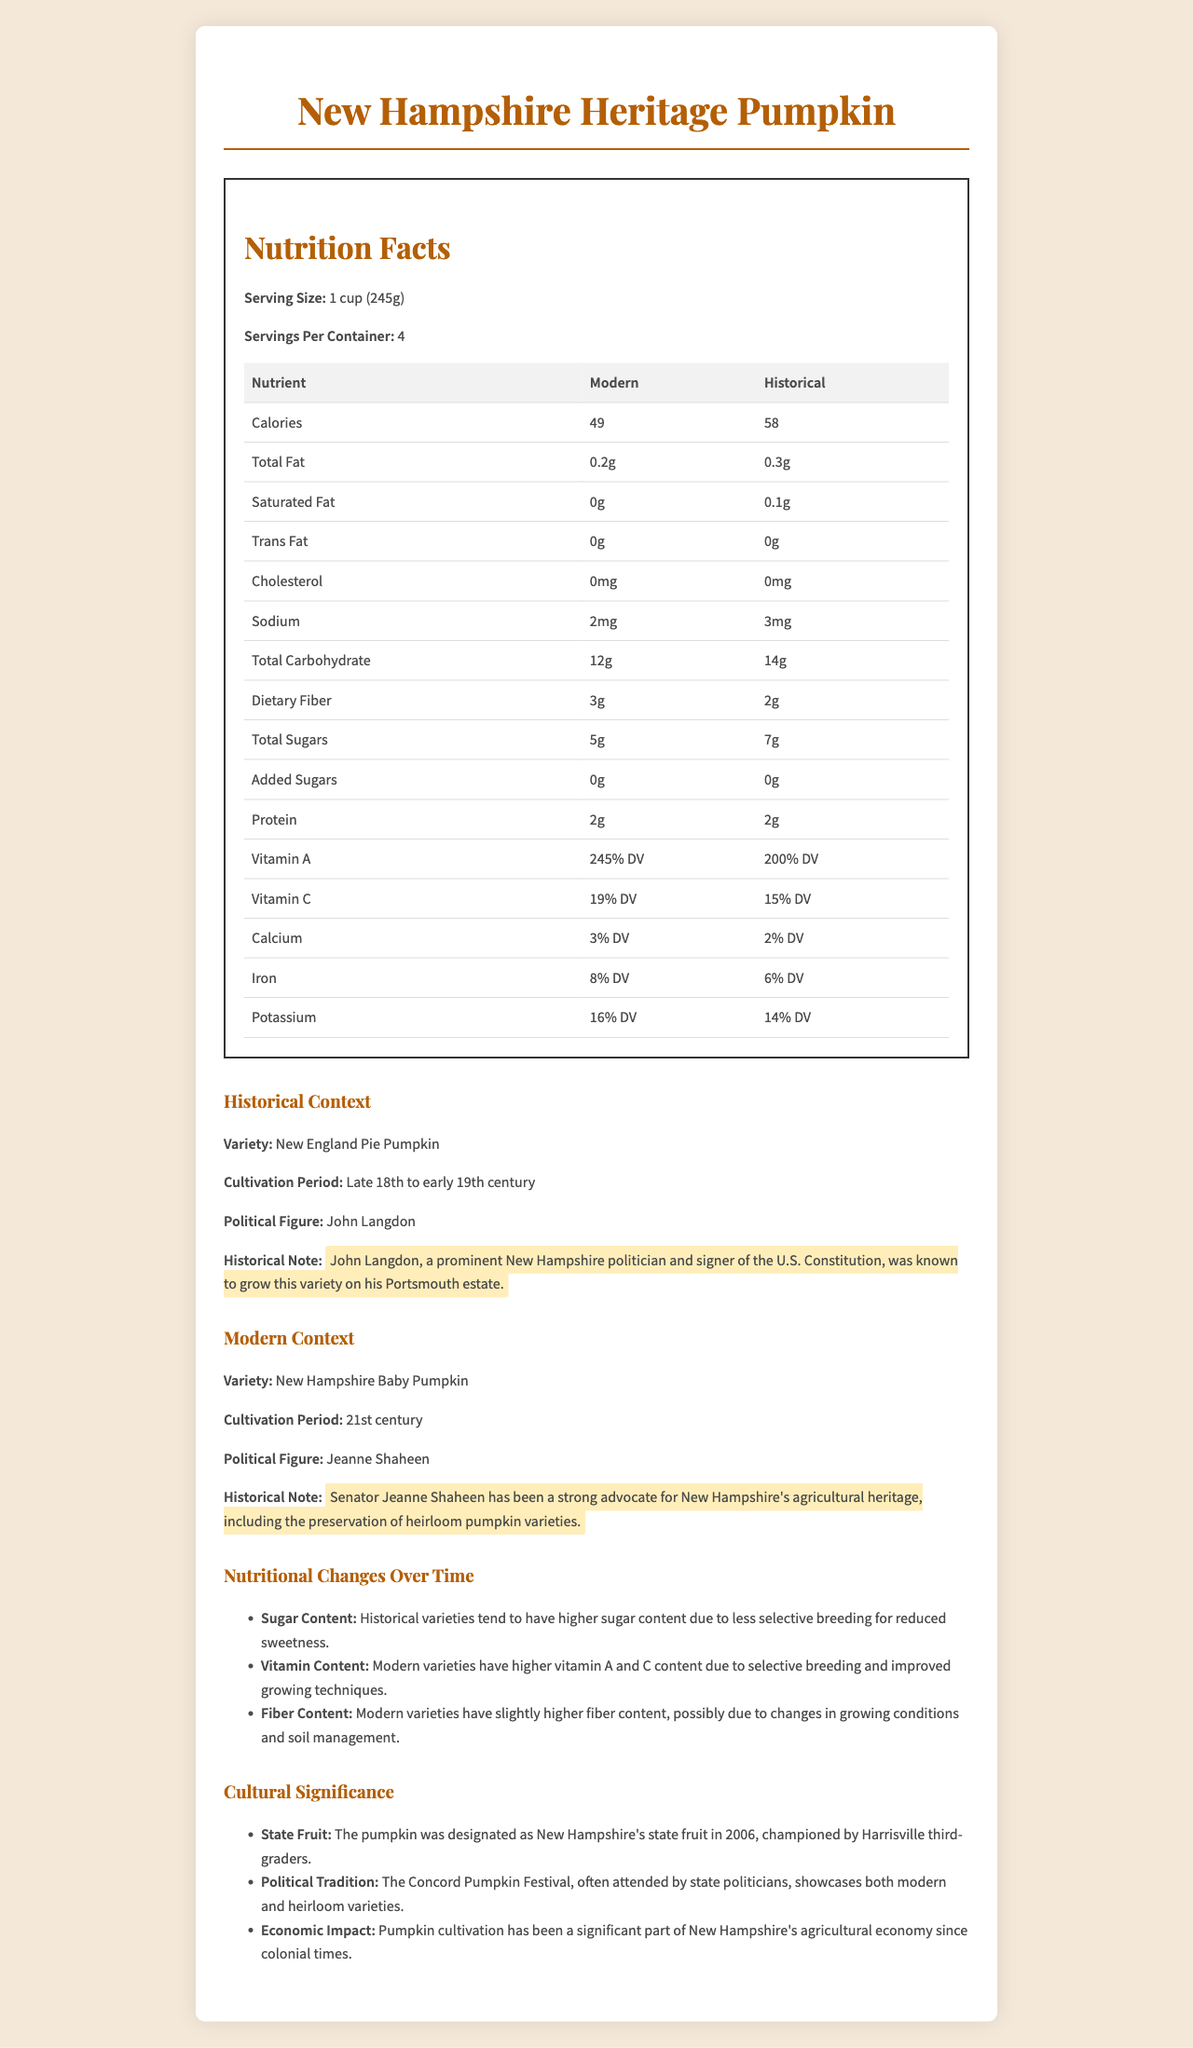what is the serving size for the New Hampshire Heritage Pumpkin? The serving size is explicitly mentioned under the Nutrition Facts section in the document.
Answer: 1 cup (245g) how many servings are there per container? The document clearly states that there are 4 servings per container.
Answer: 4 what period was the New England Pie Pumpkin cultivated? This information is given in the Historical Context section.
Answer: Late 18th to early 19th century who is the modern political figure associated with the New Hampshire Baby Pumpkin? This information is provided in the Modern Context section.
Answer: Jeanne Shaheen how does the fiber content of modern pumpkin compare to historical pumpkin? The modern variety has 3g of dietary fiber, while the historical variety has 2g.
Answer: Modern pumpkin has 1g more fiber than historical pumpkin how much vitamin A does the modern version of the pumpkin provide? A. 200% DV B. 245% DV C. 100% DV The modern version contains 245% DV of vitamin A as specified in the document.
Answer: B which variety has higher total sugars? I. Modern II. Historical The historical variety has 7g of total sugars while the modern variety only has 5g.
Answer: II do both versions of the pumpkin contain any trans fat? The document specifies 0g trans fat for both modern and historical versions.
Answer: No summarize the document. The summary captures the main ideas and the different sections of the document, which cover nutritional details, historical backgrounds, and modern context along with cultural significance.
Answer: The document provides a comparative nutritional analysis of modern and historical versions of New Hampshire's state fruit, the pumpkin. It includes detailed nutritional facts, historical and modern cultivation contexts, notable political figures associated with each variety, nutritional changes over time, and cultural significance. what is the precise cultivation period for the New Hampshire Baby Pumpkin? The document mentions only that the cultivation period is the 21st century but does not provide specific years or a more precise period.
Answer: Cannot be determined which variety has a higher percentage of Vitamin A? The modern variety of pumpkin provides 245% DV of Vitamin A compared to 200% DV in the historical variety.
Answer: Modern name the economic significance mentioned in the cultural significance section. This information is included in the Cultural Significance section under economic impact.
Answer: Pumpkin cultivation has been a significant part of New Hampshire's agricultural economy since colonial times. what change in vitamin content is mentioned in the nutritional changes section? This specific change is described under the Nutritional Changes Over Time section.
Answer: Modern varieties have higher vitamin A and C content due to selective breeding and improved growing techniques. 